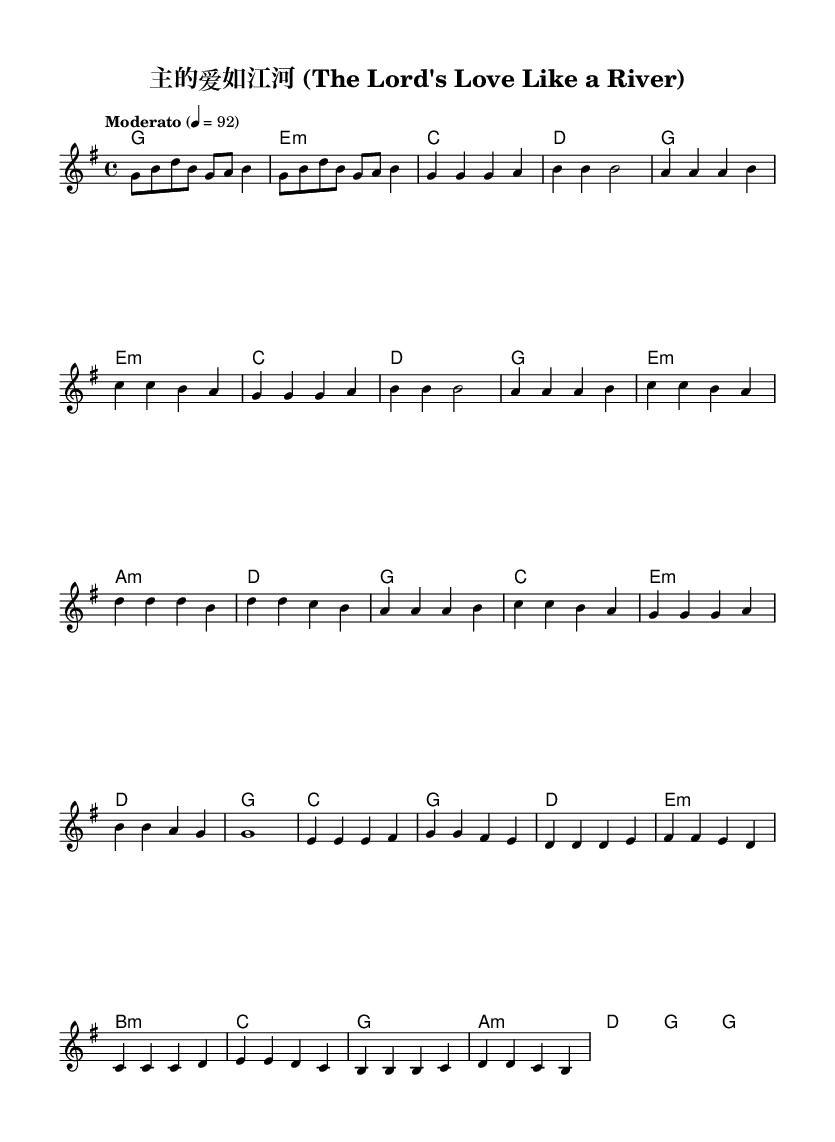What is the key signature of this music? The key signature is G major, which has one sharpened note (F#). This can be determined by looking for the key signature at the beginning of the music sheet where the F note has been raised.
Answer: G major What is the time signature of this music? The time signature is 4/4, indicated at the beginning of the score, showing there are four beats in each measure and the quarter note gets one beat.
Answer: 4/4 What is the tempo marking of this music? The tempo marking is "Moderato," which indicates a moderate pace. This is specified at the beginning of the piece, showing how quickly the music should be played.
Answer: Moderato What is the first line of the lyrics in the verse? The first line of the lyrics is "主 的 爱 如 江 河 流 向 我 心 田." This can be seen in the lyric section corresponding to the melody in the score.
Answer: 主 的 爱 如 江 河 流 向 我 心 田 How many verses are in this song? There are two verses in this song, as indicated by the structure of the lyrics where there are separate entries for verse one and verse two.
Answer: 2 Which section comes after the chorus? The section that comes after the chorus is the "Bridge," which follows naturally in the structure of the song where each part leads into the next.
Answer: Bridge What is the last line of the bridge lyrics? The last line of the bridge lyrics is "使 我 成 为 你 荣 耀 器 皿." This can be confirmed by examining the lyrics section that corresponds to the bridge section of the song.
Answer: 使 我 成 为 你 荣 耀 器 皿 